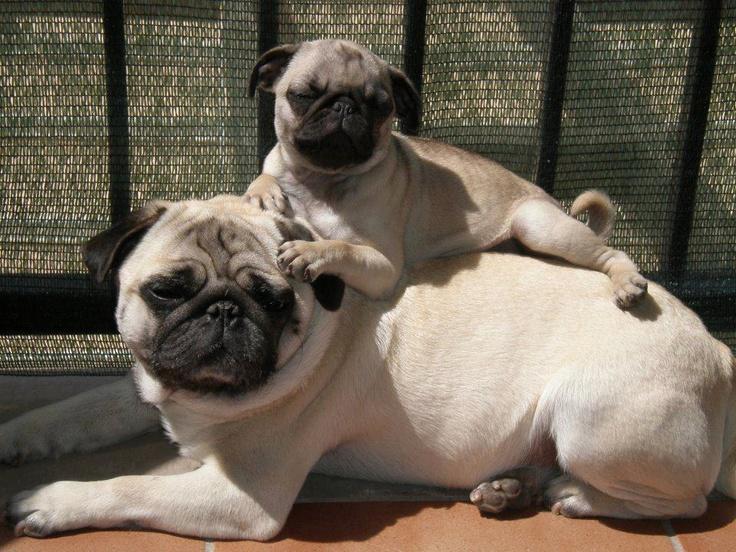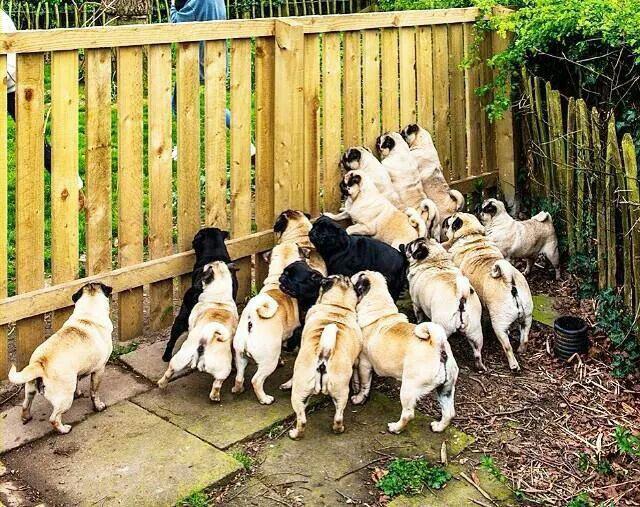The first image is the image on the left, the second image is the image on the right. For the images shown, is this caption "An image shows multiple pug dogs wearing harnesses." true? Answer yes or no. No. The first image is the image on the left, the second image is the image on the right. For the images displayed, is the sentence "A group of dogs is near a wooden fence in one of the images." factually correct? Answer yes or no. Yes. 